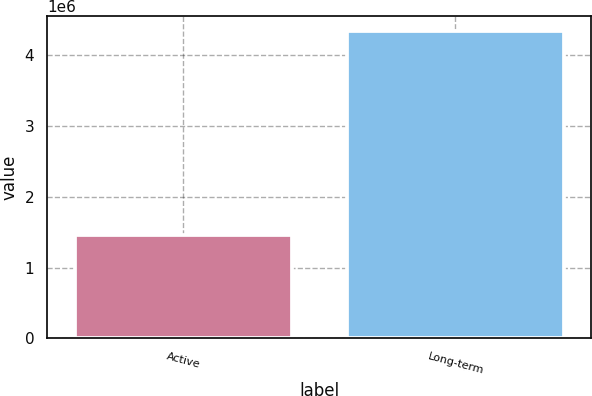<chart> <loc_0><loc_0><loc_500><loc_500><bar_chart><fcel>Active<fcel>Long-term<nl><fcel>1.45361e+06<fcel>4.33384e+06<nl></chart> 